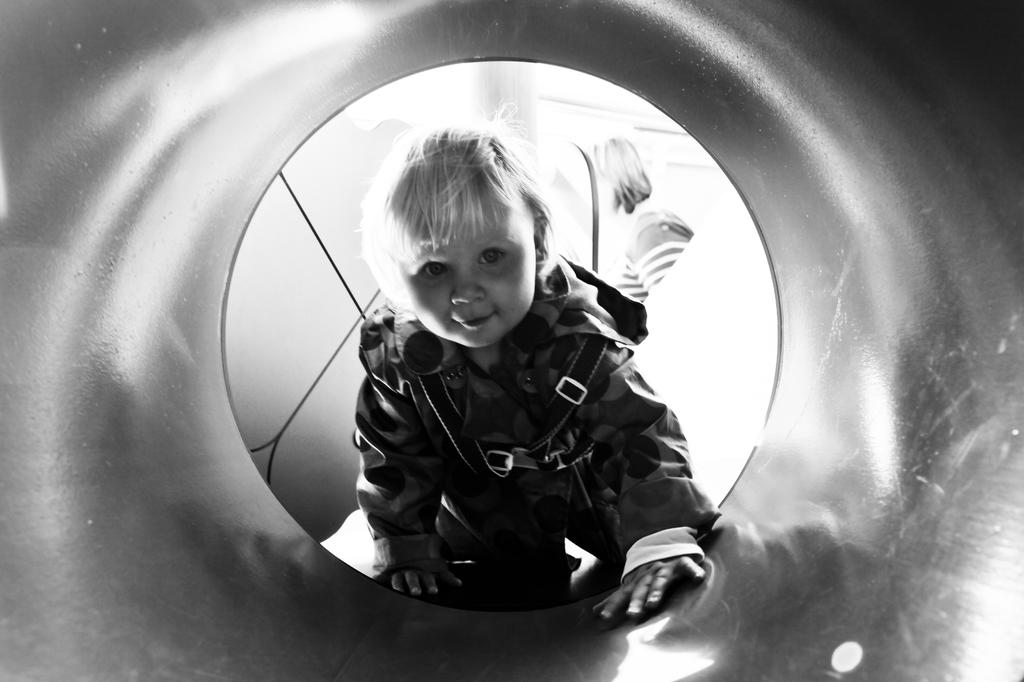What is the main subject of the image? The main subject of the image is a kid. What is the kid doing in the image? The kid is smiling in the image. Can you describe anything else in the image besides the kid? Yes, there is another person in the background of the image. What is the color scheme of the image? The image is black and white. How many porters are carrying the beds in the image? There are no porters or beds present in the image. What type of rod can be seen in the image? There is no rod present in the image. 